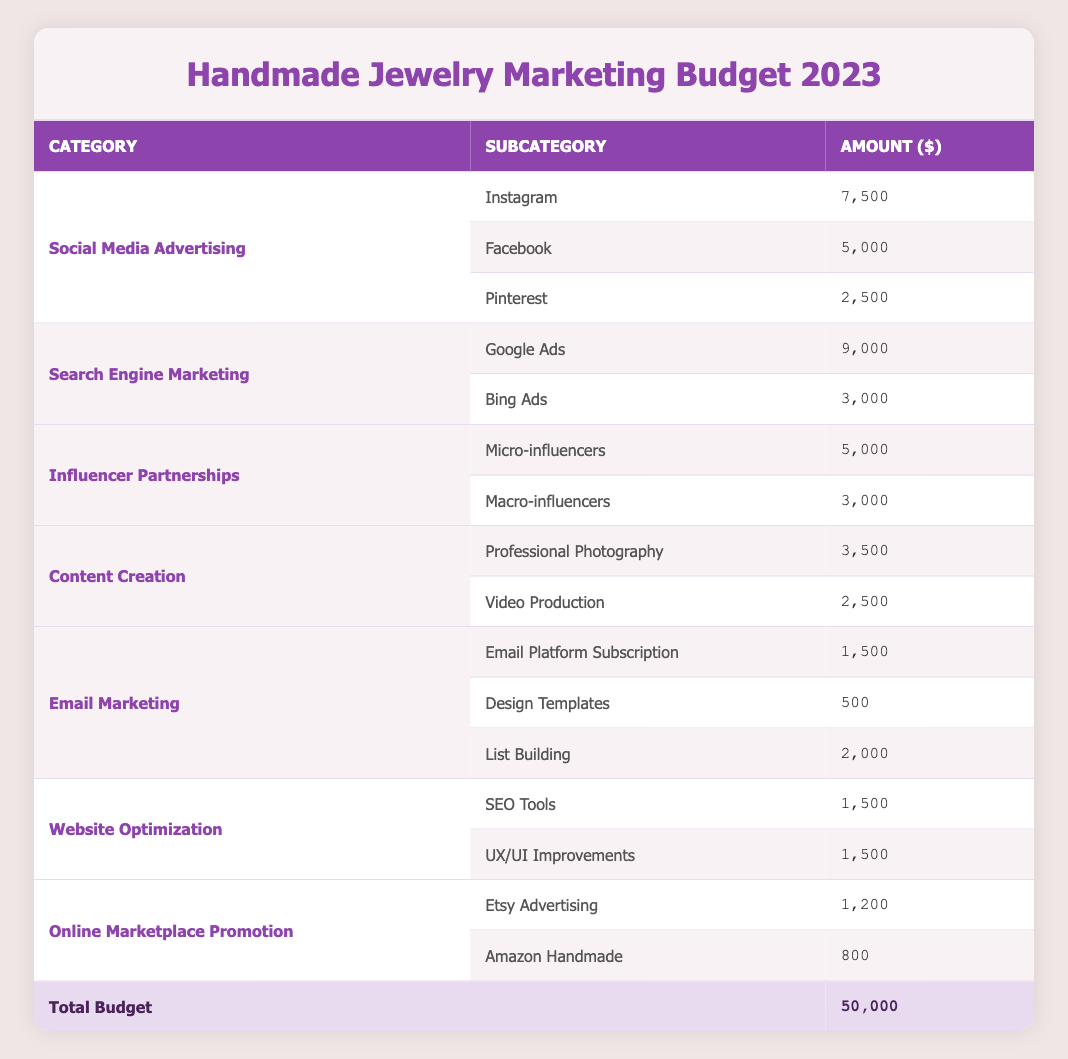What is the total marketing budget for 2023? The total marketing budget is explicitly stated in the table under the "Total Budget" row, which shows $50,000.
Answer: 50000 How much is allocated to Social Media Advertising in 2023? The allocation for Social Media Advertising is listed in the table as $15,000.
Answer: 15000 Which platform receives the highest allocation under Search Engine Marketing? In the Search Engine Marketing category, Google Ads has an allocation of $9,000, which is higher than Bing Ads at $3,000. Therefore, Google Ads receives the highest allocation.
Answer: Google Ads What percentage of the total budget is allocated to Influencer Partnerships? The allocation for Influencer Partnerships is $8,000. To find the percentage, divide $8,000 by the total budget of $50,000, which gives 0.16. Multiplying by 100 yields 16%.
Answer: 16% How much more is spent on Instagram compared to Pinterest? The allocation for Instagram is $7,500 and for Pinterest is $2,500. The difference is $7,500 - $2,500 = $5,000.
Answer: 5000 Is the budget for Email Marketing more than the budget for Website Optimization? The budget for Email Marketing is $4,000, while Website Optimization is $3,000. Since $4,000 is greater than $3,000, the statement is true.
Answer: Yes What is the total budget allocated for Content Creation? To find the total for Content Creation, we combine the amounts allocated for Professional Photography ($3,500) and Video Production ($2,500). Summing these gives $3,500 + $2,500 = $6,000.
Answer: 6000 What is the total budget allocated for online marketplace promotion? The total budget for online marketplace promotion includes Etsy Advertising ($1,200) and Amazon Handmade ($800). Adding these amounts, $1,200 + $800 equals $2,000.
Answer: 2000 Which marketing category has the least budget allocation? By reviewing the table, Online Marketplace Promotion has the least budget allocation at $2,000, while all other categories have higher allocations.
Answer: Online Marketplace Promotion 